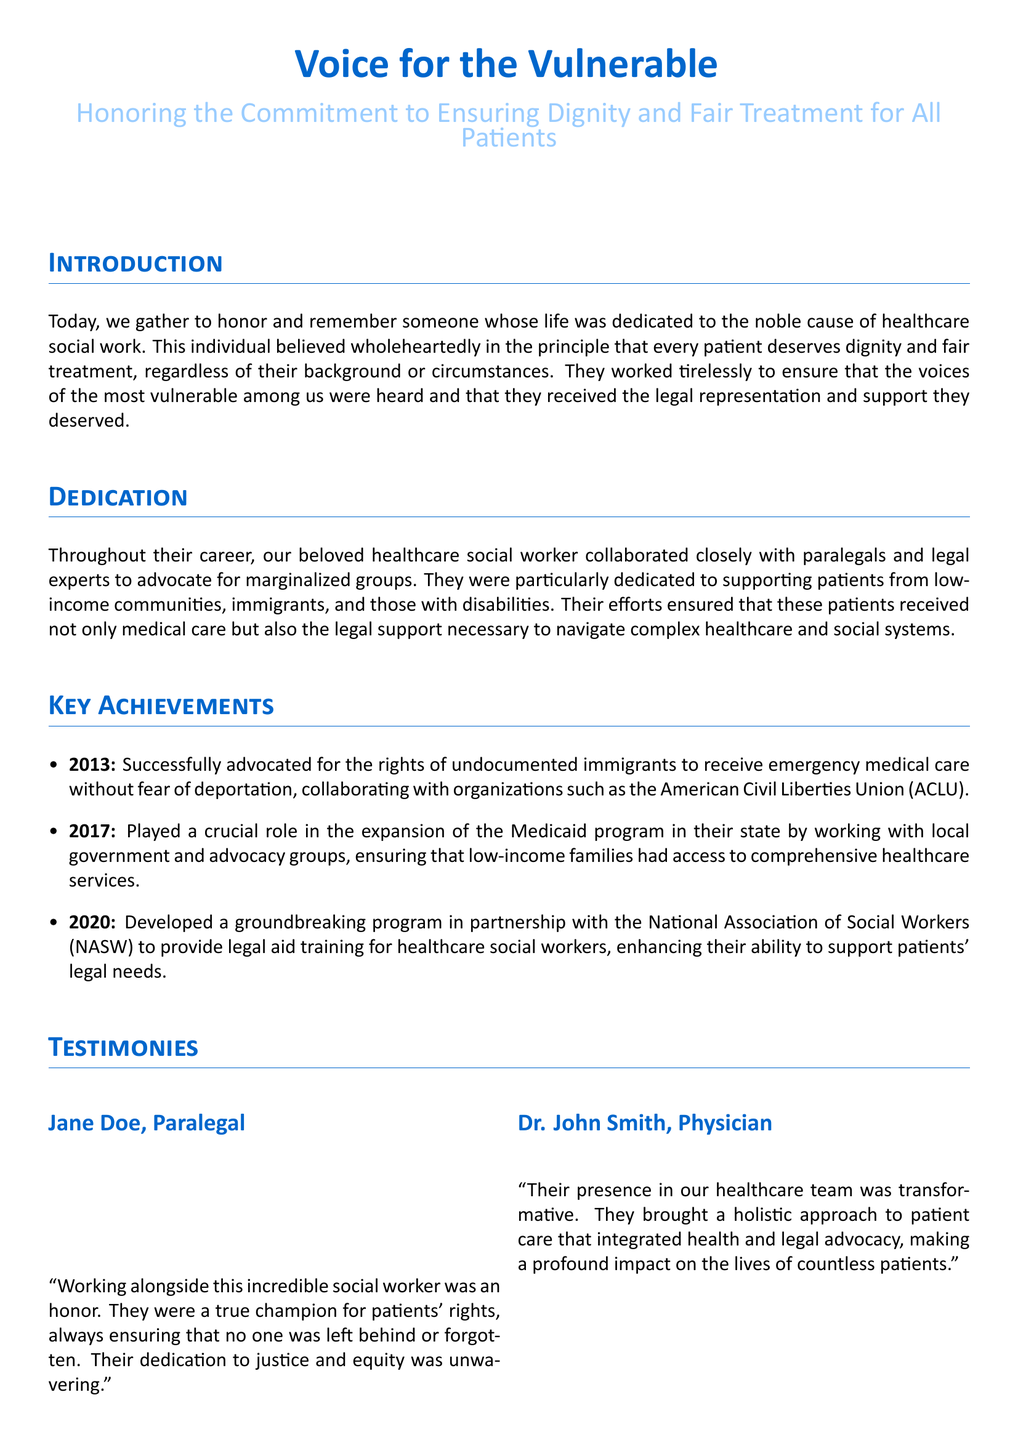What is the title of the document? The title of the document is presented prominently at the beginning, which is "Voice for the Vulnerable."
Answer: Voice for the Vulnerable What year did the social worker successfully advocate for the rights of undocumented immigrants? The document specifies the year when the social worker took this action, which is 2013.
Answer: 2013 Who collaborated with the social worker for legal representation? The document mentions that the social worker worked closely with legal experts and paralegals for advocacy.
Answer: Paralegals What was developed in partnership with the National Association of Social Workers in 2020? The document describes the initiative created in 2020 to provide legal aid training for healthcare social workers.
Answer: Legal aid training Which community was specifically mentioned as a focus for the social worker's advocacy? The document highlights that low-income communities were a significant focus for their advocacy efforts.
Answer: Low-income communities How did Dr. John Smith describe the social worker's impact on healthcare? The physician noted the transformative effect of the social worker’s holistic approach to patient care, integrating health and legal advocacy.
Answer: Transformative What type of patients did the social worker particularly advocate for? The document indicates that the social worker particularly advocated for marginalized groups among patients.
Answer: Marginalized groups What was the purpose of the program established in 2017? The program's purpose was to expand the Medicaid program, ensuring access to comprehensive healthcare services.
Answer: Expand Medicaid program What quality did the social worker demonstrate throughout their career? The document emphasizes the social worker's unwavering dedication to justice and equity.
Answer: Unwavering dedication to justice and equity 